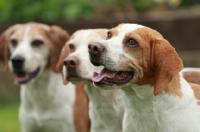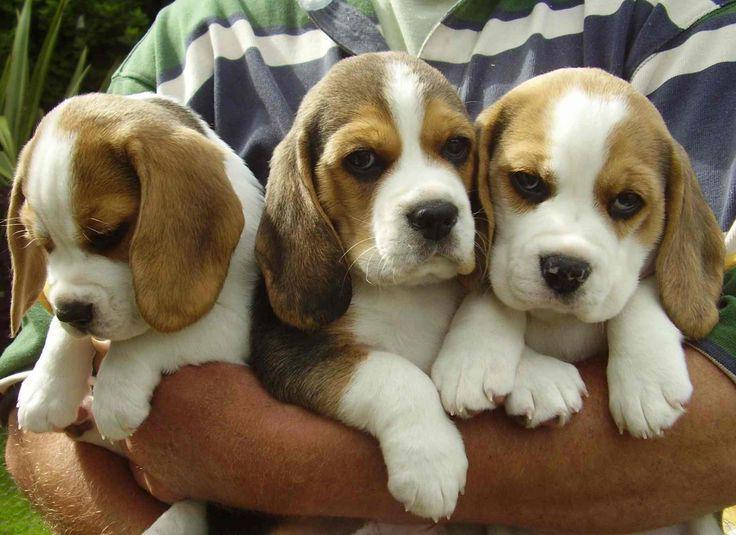The first image is the image on the left, the second image is the image on the right. Given the left and right images, does the statement "There are at least 5 puppies." hold true? Answer yes or no. Yes. 